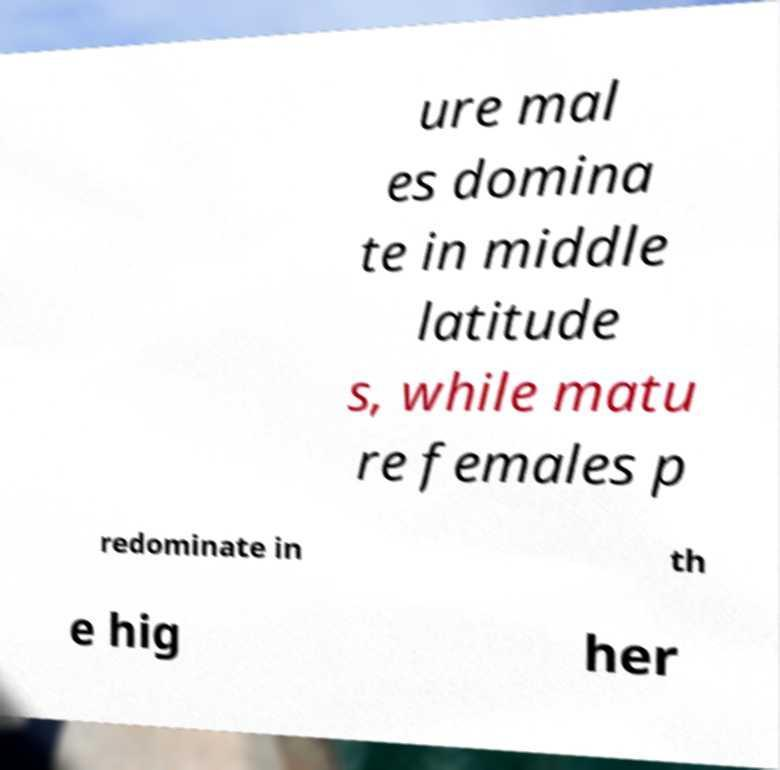For documentation purposes, I need the text within this image transcribed. Could you provide that? ure mal es domina te in middle latitude s, while matu re females p redominate in th e hig her 